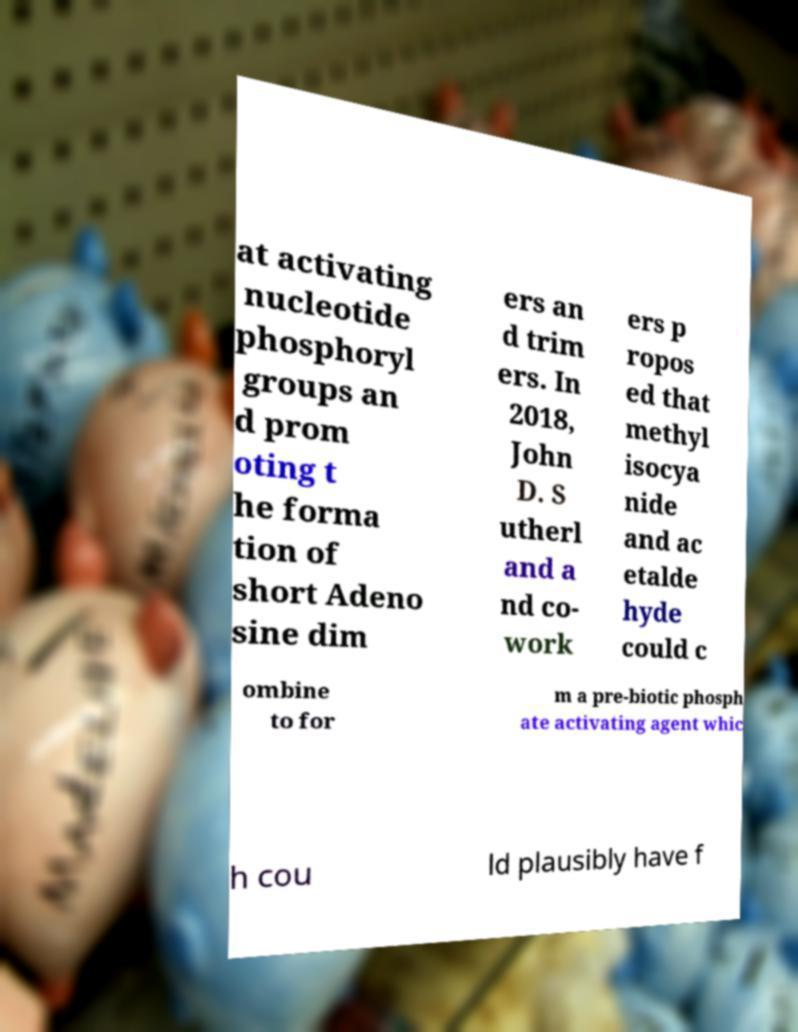I need the written content from this picture converted into text. Can you do that? at activating nucleotide phosphoryl groups an d prom oting t he forma tion of short Adeno sine dim ers an d trim ers. In 2018, John D. S utherl and a nd co- work ers p ropos ed that methyl isocya nide and ac etalde hyde could c ombine to for m a pre-biotic phosph ate activating agent whic h cou ld plausibly have f 